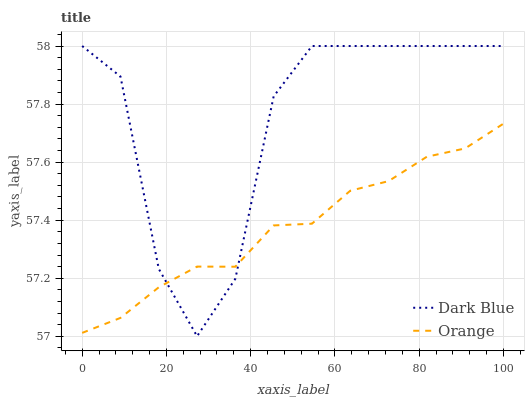Does Orange have the minimum area under the curve?
Answer yes or no. Yes. Does Dark Blue have the maximum area under the curve?
Answer yes or no. Yes. Does Dark Blue have the minimum area under the curve?
Answer yes or no. No. Is Orange the smoothest?
Answer yes or no. Yes. Is Dark Blue the roughest?
Answer yes or no. Yes. Is Dark Blue the smoothest?
Answer yes or no. No. Does Dark Blue have the lowest value?
Answer yes or no. Yes. Does Dark Blue have the highest value?
Answer yes or no. Yes. Does Orange intersect Dark Blue?
Answer yes or no. Yes. Is Orange less than Dark Blue?
Answer yes or no. No. Is Orange greater than Dark Blue?
Answer yes or no. No. 